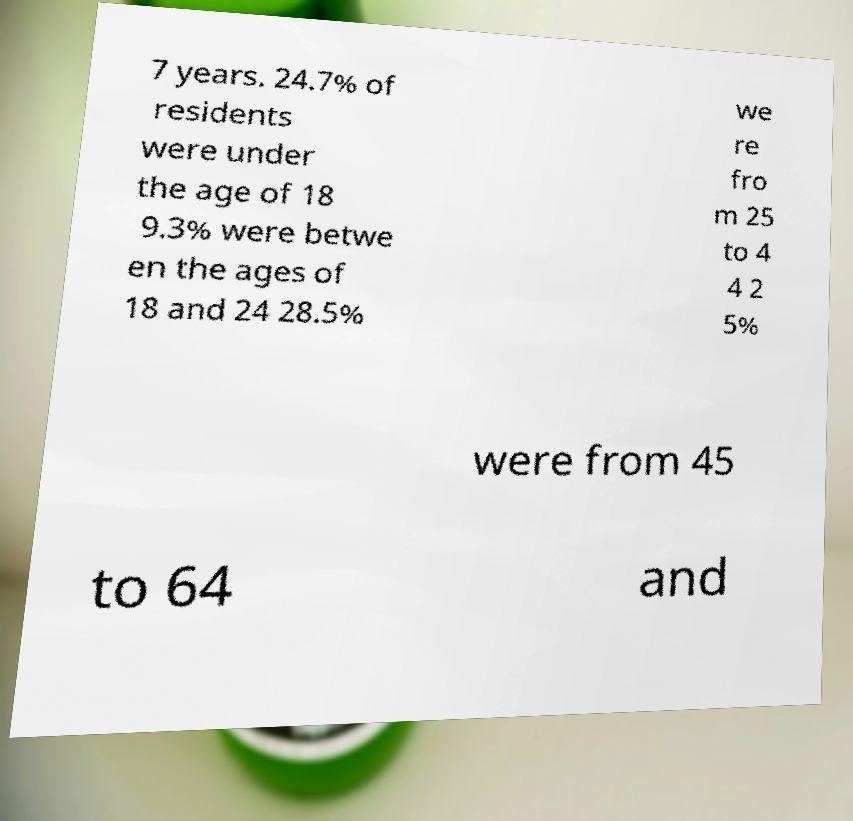What messages or text are displayed in this image? I need them in a readable, typed format. 7 years. 24.7% of residents were under the age of 18 9.3% were betwe en the ages of 18 and 24 28.5% we re fro m 25 to 4 4 2 5% were from 45 to 64 and 